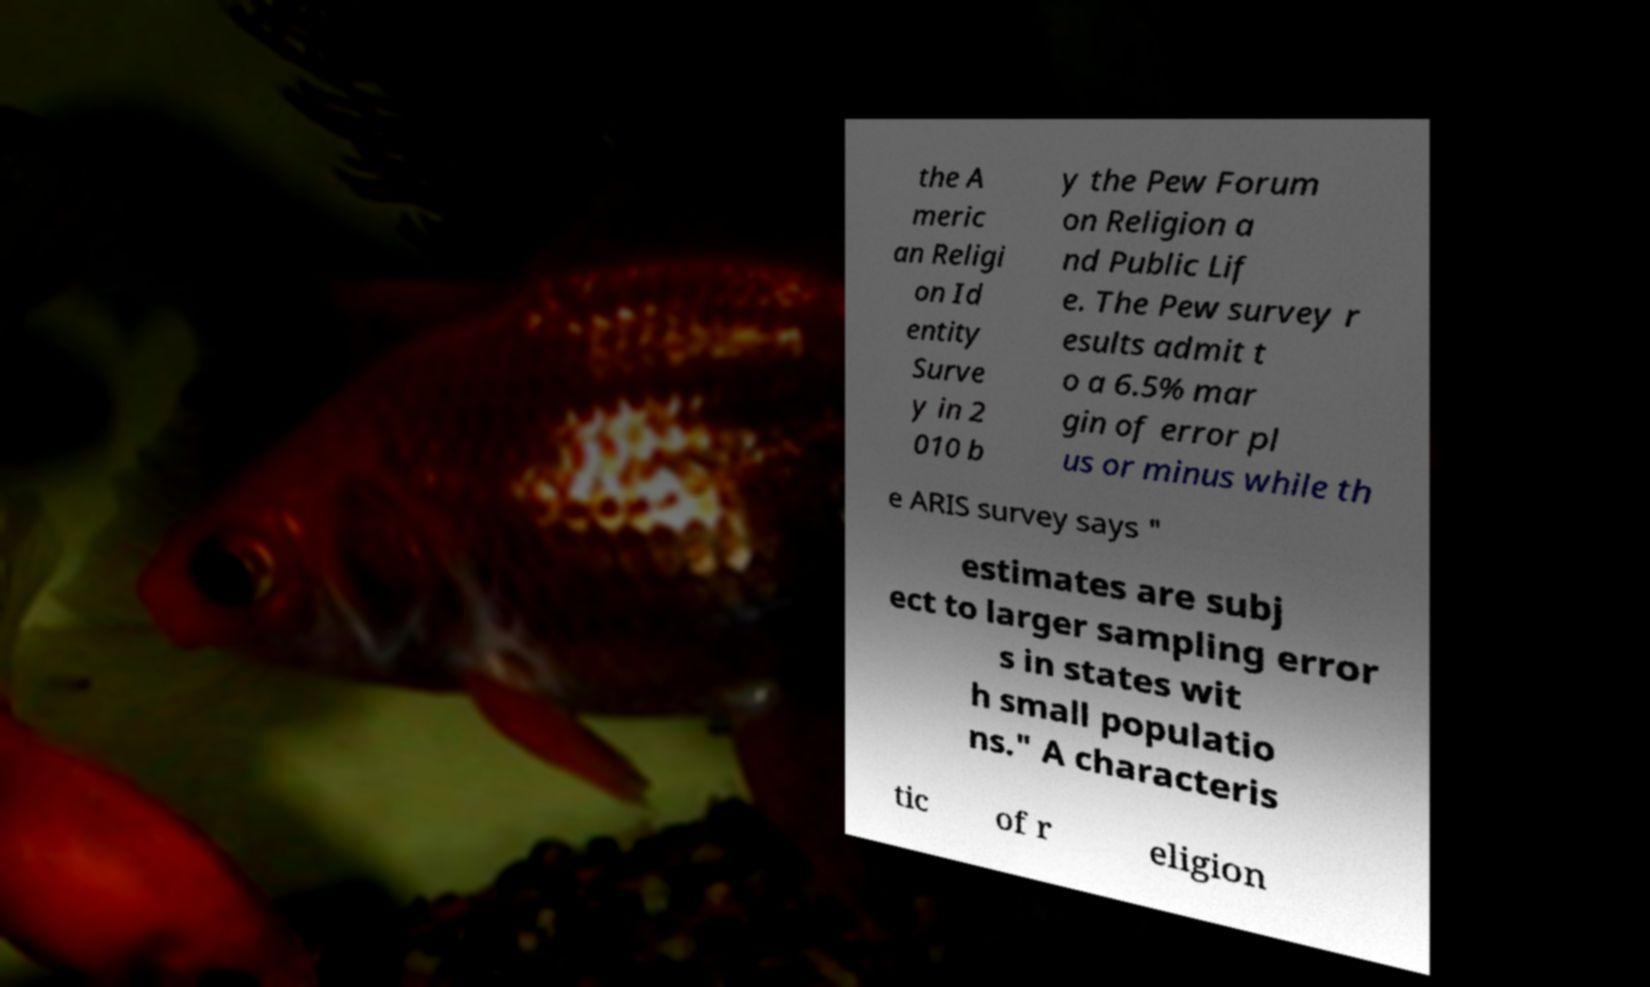I need the written content from this picture converted into text. Can you do that? the A meric an Religi on Id entity Surve y in 2 010 b y the Pew Forum on Religion a nd Public Lif e. The Pew survey r esults admit t o a 6.5% mar gin of error pl us or minus while th e ARIS survey says " estimates are subj ect to larger sampling error s in states wit h small populatio ns." A characteris tic of r eligion 